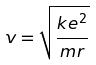<formula> <loc_0><loc_0><loc_500><loc_500>v = \sqrt { \frac { k e ^ { 2 } } { m r } }</formula> 